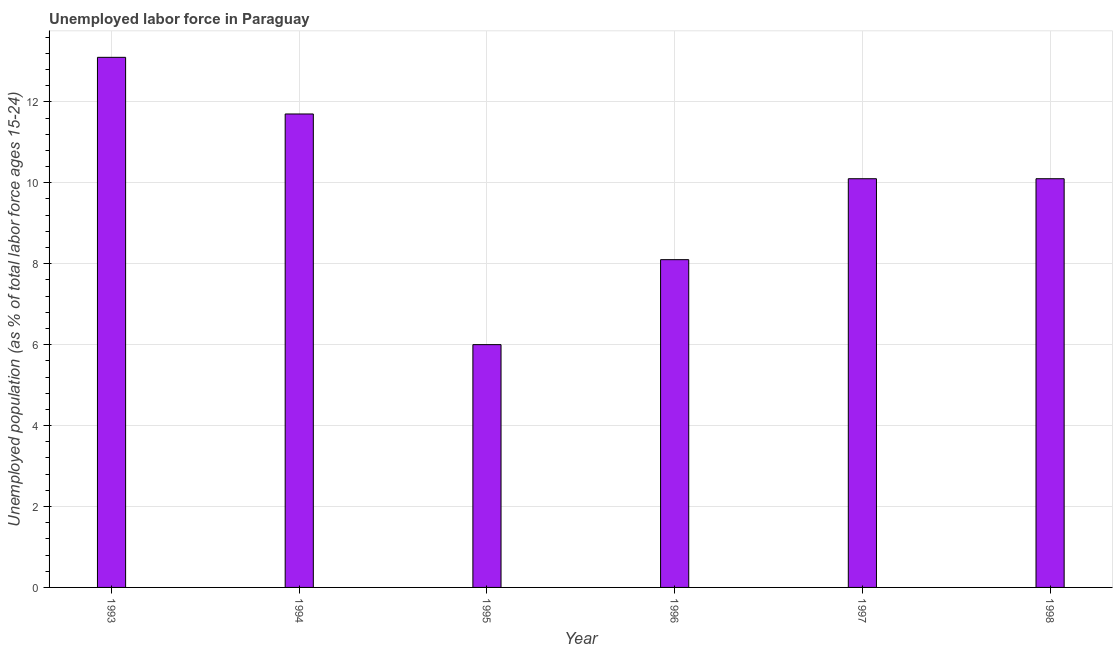What is the title of the graph?
Ensure brevity in your answer.  Unemployed labor force in Paraguay. What is the label or title of the Y-axis?
Offer a very short reply. Unemployed population (as % of total labor force ages 15-24). What is the total unemployed youth population in 1997?
Provide a succinct answer. 10.1. Across all years, what is the maximum total unemployed youth population?
Provide a succinct answer. 13.1. What is the sum of the total unemployed youth population?
Provide a succinct answer. 59.1. What is the average total unemployed youth population per year?
Your response must be concise. 9.85. What is the median total unemployed youth population?
Your answer should be compact. 10.1. What is the ratio of the total unemployed youth population in 1995 to that in 1997?
Your response must be concise. 0.59. What is the difference between the highest and the second highest total unemployed youth population?
Keep it short and to the point. 1.4. How many bars are there?
Offer a terse response. 6. Are all the bars in the graph horizontal?
Ensure brevity in your answer.  No. How many years are there in the graph?
Your answer should be very brief. 6. What is the difference between two consecutive major ticks on the Y-axis?
Your answer should be compact. 2. What is the Unemployed population (as % of total labor force ages 15-24) in 1993?
Provide a succinct answer. 13.1. What is the Unemployed population (as % of total labor force ages 15-24) in 1994?
Provide a succinct answer. 11.7. What is the Unemployed population (as % of total labor force ages 15-24) of 1996?
Make the answer very short. 8.1. What is the Unemployed population (as % of total labor force ages 15-24) in 1997?
Provide a succinct answer. 10.1. What is the Unemployed population (as % of total labor force ages 15-24) in 1998?
Make the answer very short. 10.1. What is the difference between the Unemployed population (as % of total labor force ages 15-24) in 1993 and 1994?
Ensure brevity in your answer.  1.4. What is the difference between the Unemployed population (as % of total labor force ages 15-24) in 1993 and 1995?
Your answer should be compact. 7.1. What is the difference between the Unemployed population (as % of total labor force ages 15-24) in 1993 and 1997?
Your answer should be very brief. 3. What is the difference between the Unemployed population (as % of total labor force ages 15-24) in 1994 and 1995?
Your response must be concise. 5.7. What is the difference between the Unemployed population (as % of total labor force ages 15-24) in 1994 and 1998?
Offer a terse response. 1.6. What is the difference between the Unemployed population (as % of total labor force ages 15-24) in 1995 and 1996?
Provide a short and direct response. -2.1. What is the difference between the Unemployed population (as % of total labor force ages 15-24) in 1996 and 1997?
Keep it short and to the point. -2. What is the ratio of the Unemployed population (as % of total labor force ages 15-24) in 1993 to that in 1994?
Keep it short and to the point. 1.12. What is the ratio of the Unemployed population (as % of total labor force ages 15-24) in 1993 to that in 1995?
Give a very brief answer. 2.18. What is the ratio of the Unemployed population (as % of total labor force ages 15-24) in 1993 to that in 1996?
Your answer should be very brief. 1.62. What is the ratio of the Unemployed population (as % of total labor force ages 15-24) in 1993 to that in 1997?
Ensure brevity in your answer.  1.3. What is the ratio of the Unemployed population (as % of total labor force ages 15-24) in 1993 to that in 1998?
Offer a terse response. 1.3. What is the ratio of the Unemployed population (as % of total labor force ages 15-24) in 1994 to that in 1995?
Your response must be concise. 1.95. What is the ratio of the Unemployed population (as % of total labor force ages 15-24) in 1994 to that in 1996?
Provide a succinct answer. 1.44. What is the ratio of the Unemployed population (as % of total labor force ages 15-24) in 1994 to that in 1997?
Offer a terse response. 1.16. What is the ratio of the Unemployed population (as % of total labor force ages 15-24) in 1994 to that in 1998?
Provide a succinct answer. 1.16. What is the ratio of the Unemployed population (as % of total labor force ages 15-24) in 1995 to that in 1996?
Provide a short and direct response. 0.74. What is the ratio of the Unemployed population (as % of total labor force ages 15-24) in 1995 to that in 1997?
Provide a short and direct response. 0.59. What is the ratio of the Unemployed population (as % of total labor force ages 15-24) in 1995 to that in 1998?
Your response must be concise. 0.59. What is the ratio of the Unemployed population (as % of total labor force ages 15-24) in 1996 to that in 1997?
Offer a very short reply. 0.8. What is the ratio of the Unemployed population (as % of total labor force ages 15-24) in 1996 to that in 1998?
Offer a terse response. 0.8. What is the ratio of the Unemployed population (as % of total labor force ages 15-24) in 1997 to that in 1998?
Offer a terse response. 1. 